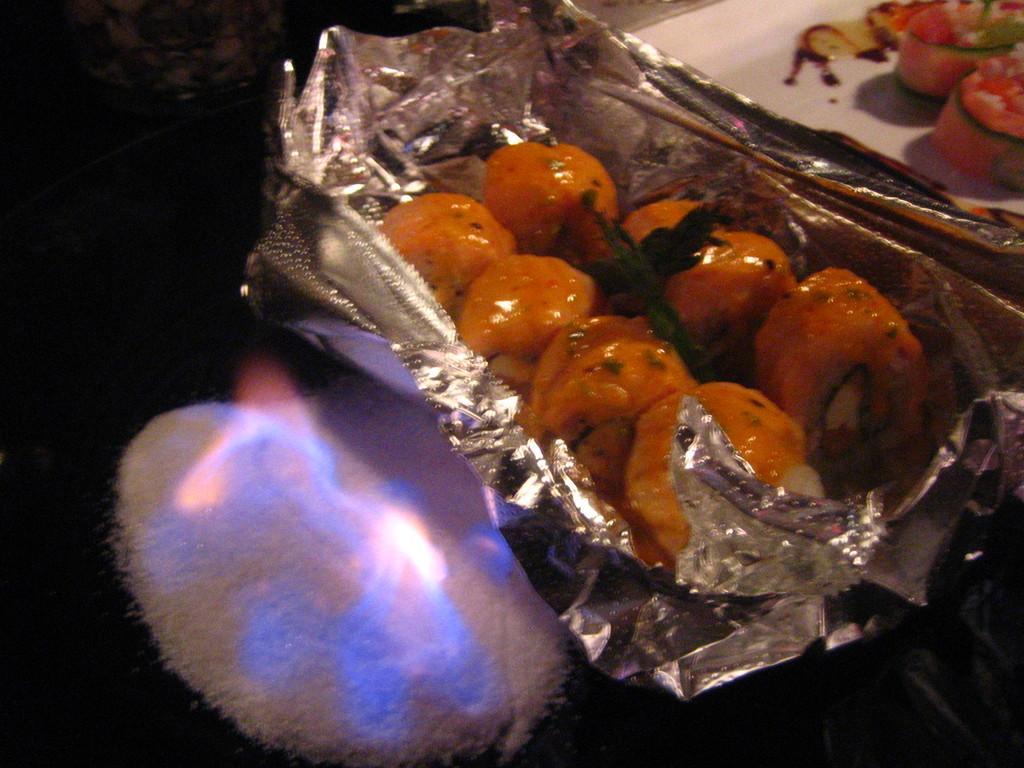Please provide a concise description of this image. In this image I can see food, plate, container and fire.   